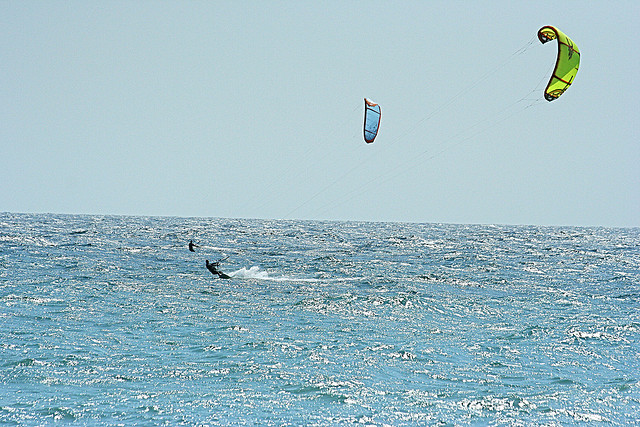<image>Are these sky surfers moving fast? I don't know if the sky surfers are moving fast or not. Are these sky surfers moving fast? I don't know if these sky surfers are moving fast. It can be both yes and no. 